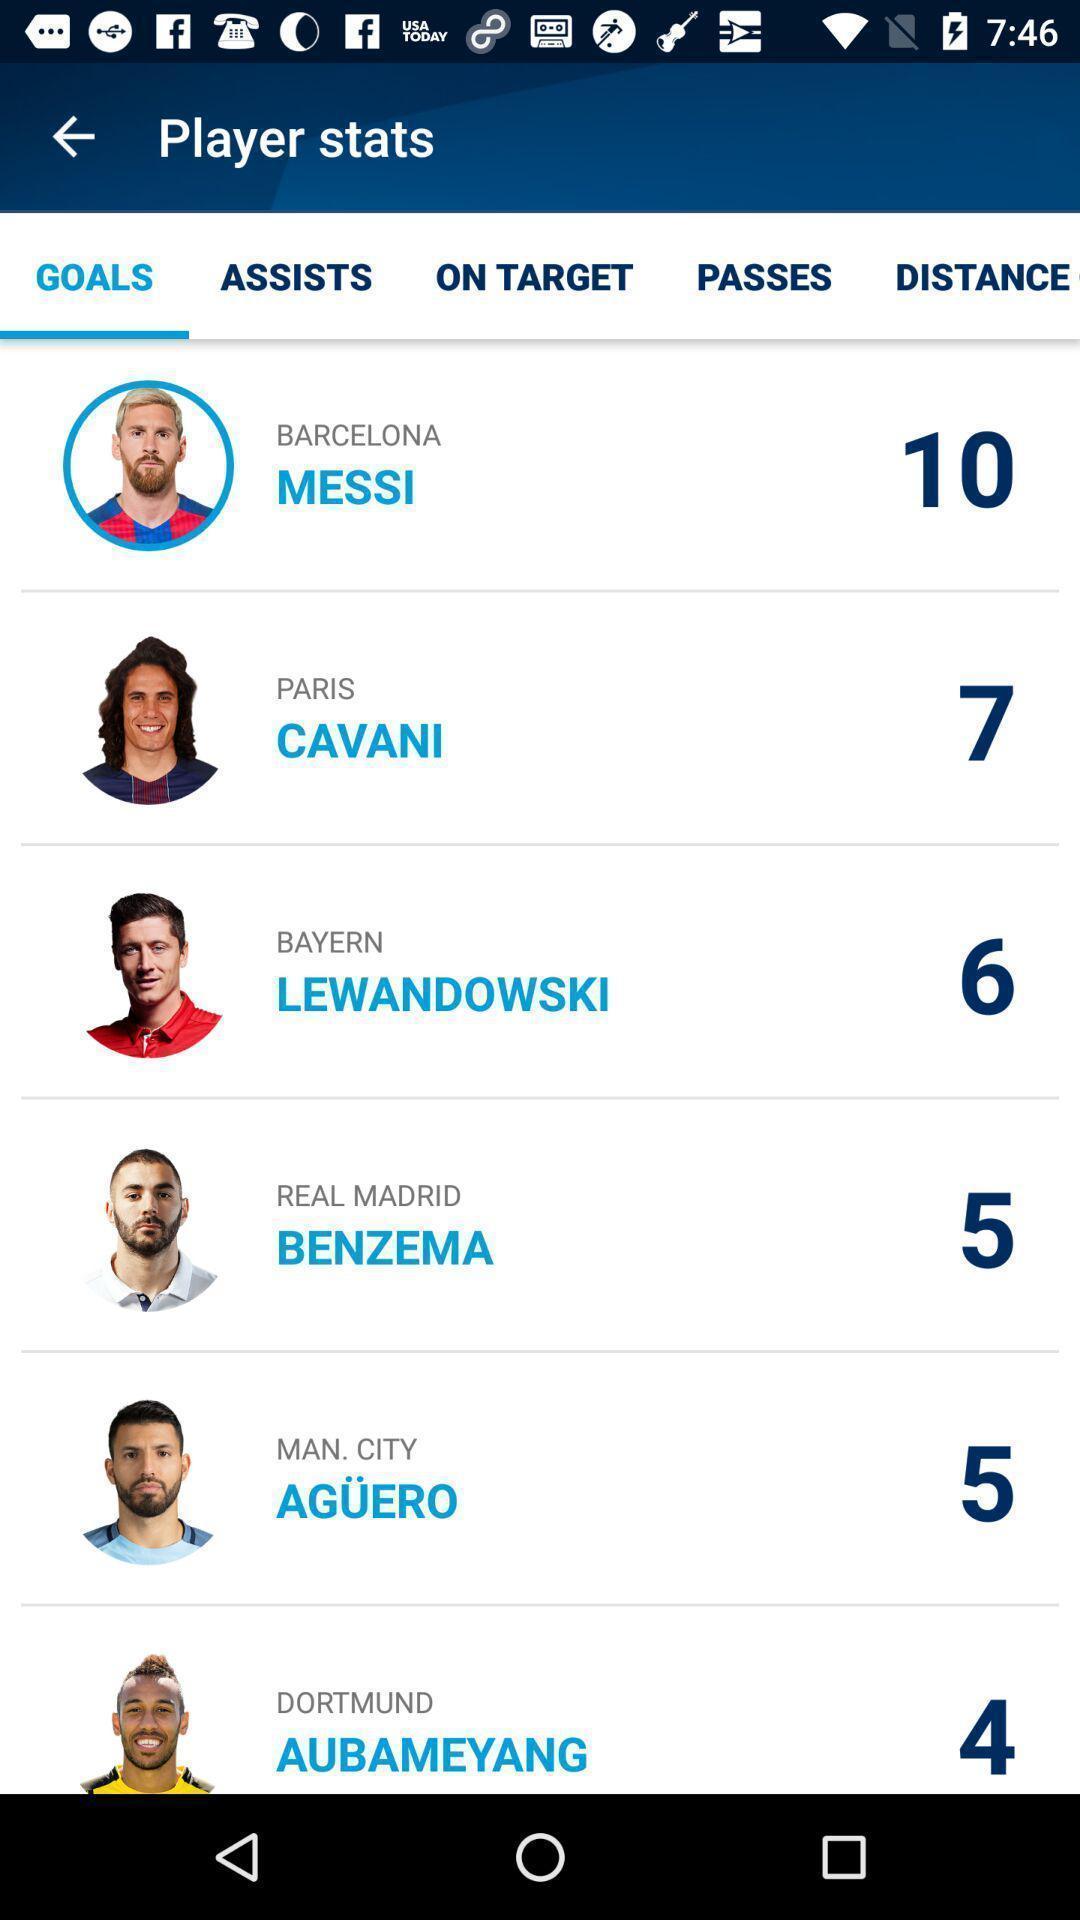What can you discern from this picture? Screen page displaying various profiles in sports application. 